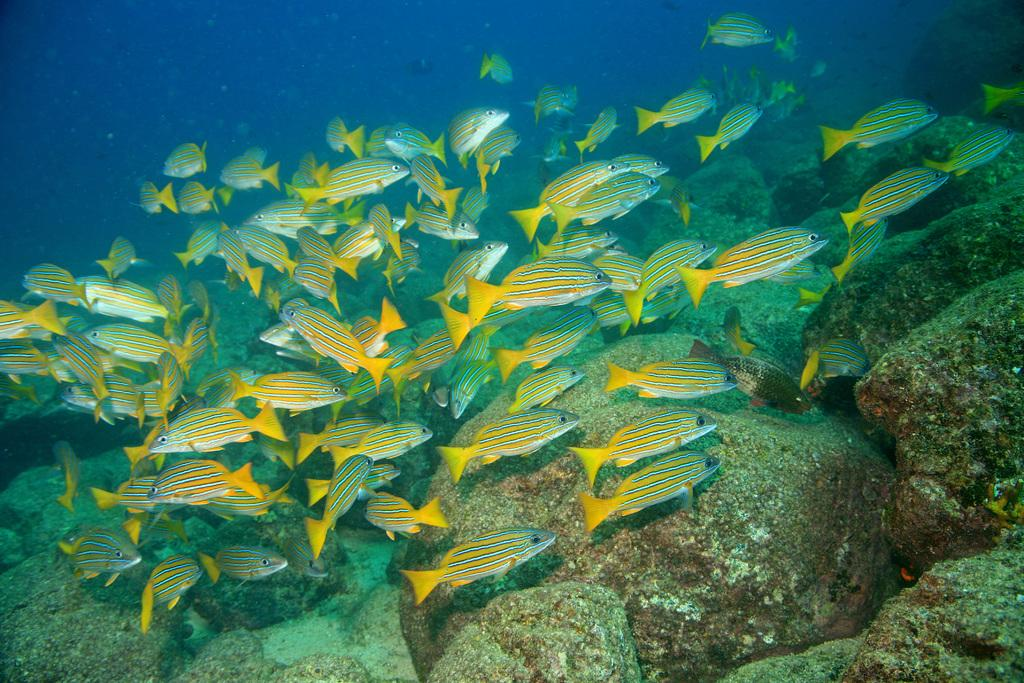What type of animals can be seen in the water in the image? There are fishes in the water in the image. What else can be seen under the water in the image? There are stones under the water in the image. What type of nut can be seen floating on the water in the image? There is no nut visible in the image; it only features fishes and stones under the water. 